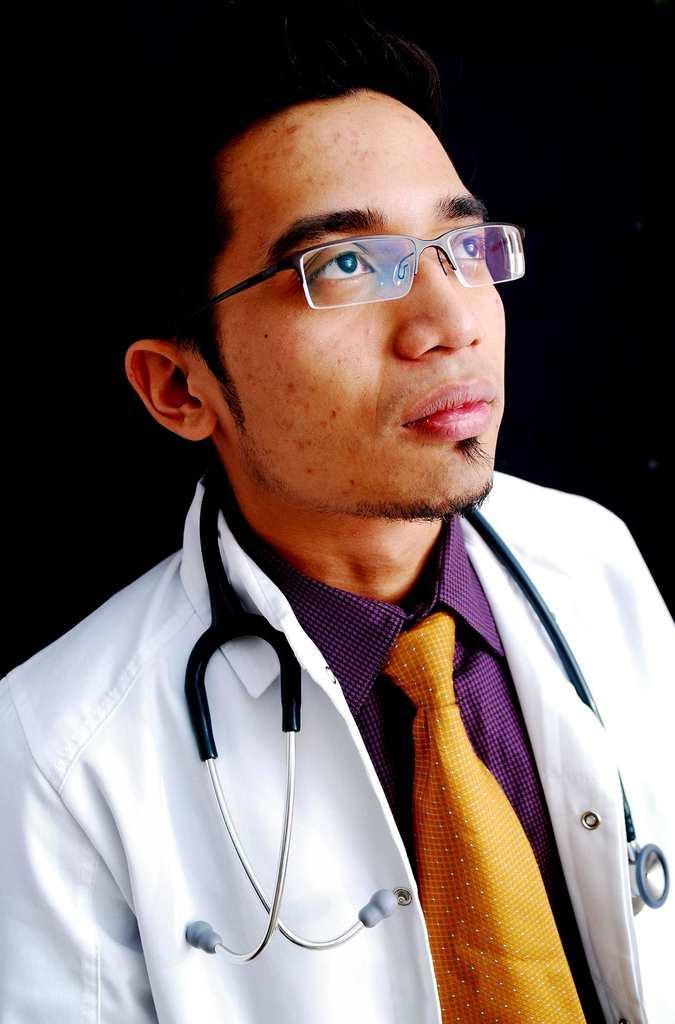How would you summarize this image in a sentence or two? In this picture there is a man who is wearing shirt, tie, apron, stethoscope and spectacle. In the back I can see the darkness. 